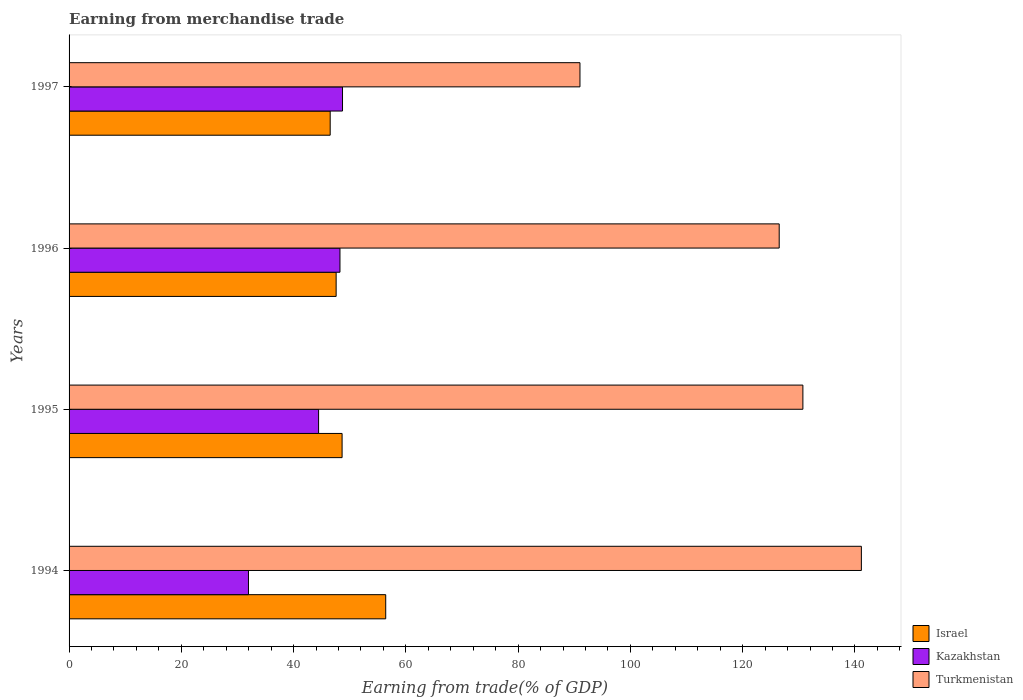How many different coloured bars are there?
Make the answer very short. 3. How many groups of bars are there?
Your response must be concise. 4. Are the number of bars on each tick of the Y-axis equal?
Offer a terse response. Yes. How many bars are there on the 3rd tick from the top?
Provide a short and direct response. 3. How many bars are there on the 4th tick from the bottom?
Your answer should be very brief. 3. What is the label of the 3rd group of bars from the top?
Make the answer very short. 1995. In how many cases, is the number of bars for a given year not equal to the number of legend labels?
Your response must be concise. 0. What is the earnings from trade in Israel in 1996?
Provide a short and direct response. 47.58. Across all years, what is the maximum earnings from trade in Kazakhstan?
Provide a short and direct response. 48.71. Across all years, what is the minimum earnings from trade in Kazakhstan?
Give a very brief answer. 31.96. In which year was the earnings from trade in Israel maximum?
Provide a short and direct response. 1994. What is the total earnings from trade in Turkmenistan in the graph?
Keep it short and to the point. 489.4. What is the difference between the earnings from trade in Kazakhstan in 1994 and that in 1995?
Your answer should be very brief. -12.49. What is the difference between the earnings from trade in Turkmenistan in 1994 and the earnings from trade in Kazakhstan in 1995?
Make the answer very short. 96.7. What is the average earnings from trade in Kazakhstan per year?
Offer a terse response. 43.35. In the year 1994, what is the difference between the earnings from trade in Kazakhstan and earnings from trade in Turkmenistan?
Your response must be concise. -109.19. In how many years, is the earnings from trade in Kazakhstan greater than 52 %?
Offer a very short reply. 0. What is the ratio of the earnings from trade in Israel in 1996 to that in 1997?
Your response must be concise. 1.02. What is the difference between the highest and the second highest earnings from trade in Israel?
Give a very brief answer. 7.77. What is the difference between the highest and the lowest earnings from trade in Turkmenistan?
Ensure brevity in your answer.  50.13. In how many years, is the earnings from trade in Israel greater than the average earnings from trade in Israel taken over all years?
Your answer should be very brief. 1. What does the 2nd bar from the top in 1995 represents?
Keep it short and to the point. Kazakhstan. What does the 2nd bar from the bottom in 1996 represents?
Ensure brevity in your answer.  Kazakhstan. How many years are there in the graph?
Your response must be concise. 4. What is the difference between two consecutive major ticks on the X-axis?
Offer a very short reply. 20. Are the values on the major ticks of X-axis written in scientific E-notation?
Offer a very short reply. No. Does the graph contain any zero values?
Your answer should be compact. No. How many legend labels are there?
Make the answer very short. 3. What is the title of the graph?
Your response must be concise. Earning from merchandise trade. What is the label or title of the X-axis?
Give a very brief answer. Earning from trade(% of GDP). What is the Earning from trade(% of GDP) in Israel in 1994?
Provide a short and direct response. 56.41. What is the Earning from trade(% of GDP) in Kazakhstan in 1994?
Make the answer very short. 31.96. What is the Earning from trade(% of GDP) of Turkmenistan in 1994?
Ensure brevity in your answer.  141.15. What is the Earning from trade(% of GDP) of Israel in 1995?
Your response must be concise. 48.64. What is the Earning from trade(% of GDP) of Kazakhstan in 1995?
Offer a terse response. 44.45. What is the Earning from trade(% of GDP) in Turkmenistan in 1995?
Your answer should be compact. 130.73. What is the Earning from trade(% of GDP) of Israel in 1996?
Offer a very short reply. 47.58. What is the Earning from trade(% of GDP) in Kazakhstan in 1996?
Provide a short and direct response. 48.26. What is the Earning from trade(% of GDP) of Turkmenistan in 1996?
Offer a very short reply. 126.51. What is the Earning from trade(% of GDP) of Israel in 1997?
Ensure brevity in your answer.  46.52. What is the Earning from trade(% of GDP) in Kazakhstan in 1997?
Your response must be concise. 48.71. What is the Earning from trade(% of GDP) in Turkmenistan in 1997?
Your answer should be very brief. 91.02. Across all years, what is the maximum Earning from trade(% of GDP) of Israel?
Provide a short and direct response. 56.41. Across all years, what is the maximum Earning from trade(% of GDP) in Kazakhstan?
Keep it short and to the point. 48.71. Across all years, what is the maximum Earning from trade(% of GDP) of Turkmenistan?
Offer a very short reply. 141.15. Across all years, what is the minimum Earning from trade(% of GDP) of Israel?
Give a very brief answer. 46.52. Across all years, what is the minimum Earning from trade(% of GDP) of Kazakhstan?
Provide a succinct answer. 31.96. Across all years, what is the minimum Earning from trade(% of GDP) of Turkmenistan?
Your response must be concise. 91.02. What is the total Earning from trade(% of GDP) in Israel in the graph?
Your answer should be very brief. 199.15. What is the total Earning from trade(% of GDP) in Kazakhstan in the graph?
Offer a very short reply. 173.39. What is the total Earning from trade(% of GDP) of Turkmenistan in the graph?
Keep it short and to the point. 489.4. What is the difference between the Earning from trade(% of GDP) of Israel in 1994 and that in 1995?
Ensure brevity in your answer.  7.77. What is the difference between the Earning from trade(% of GDP) in Kazakhstan in 1994 and that in 1995?
Your answer should be very brief. -12.49. What is the difference between the Earning from trade(% of GDP) in Turkmenistan in 1994 and that in 1995?
Your response must be concise. 10.42. What is the difference between the Earning from trade(% of GDP) of Israel in 1994 and that in 1996?
Give a very brief answer. 8.83. What is the difference between the Earning from trade(% of GDP) of Kazakhstan in 1994 and that in 1996?
Ensure brevity in your answer.  -16.3. What is the difference between the Earning from trade(% of GDP) of Turkmenistan in 1994 and that in 1996?
Give a very brief answer. 14.64. What is the difference between the Earning from trade(% of GDP) of Israel in 1994 and that in 1997?
Ensure brevity in your answer.  9.89. What is the difference between the Earning from trade(% of GDP) in Kazakhstan in 1994 and that in 1997?
Offer a terse response. -16.75. What is the difference between the Earning from trade(% of GDP) in Turkmenistan in 1994 and that in 1997?
Ensure brevity in your answer.  50.13. What is the difference between the Earning from trade(% of GDP) of Israel in 1995 and that in 1996?
Ensure brevity in your answer.  1.06. What is the difference between the Earning from trade(% of GDP) of Kazakhstan in 1995 and that in 1996?
Offer a terse response. -3.81. What is the difference between the Earning from trade(% of GDP) of Turkmenistan in 1995 and that in 1996?
Offer a very short reply. 4.22. What is the difference between the Earning from trade(% of GDP) of Israel in 1995 and that in 1997?
Make the answer very short. 2.12. What is the difference between the Earning from trade(% of GDP) of Kazakhstan in 1995 and that in 1997?
Your answer should be very brief. -4.26. What is the difference between the Earning from trade(% of GDP) of Turkmenistan in 1995 and that in 1997?
Your answer should be compact. 39.71. What is the difference between the Earning from trade(% of GDP) in Israel in 1996 and that in 1997?
Your answer should be very brief. 1.06. What is the difference between the Earning from trade(% of GDP) in Kazakhstan in 1996 and that in 1997?
Keep it short and to the point. -0.45. What is the difference between the Earning from trade(% of GDP) of Turkmenistan in 1996 and that in 1997?
Your response must be concise. 35.49. What is the difference between the Earning from trade(% of GDP) of Israel in 1994 and the Earning from trade(% of GDP) of Kazakhstan in 1995?
Keep it short and to the point. 11.96. What is the difference between the Earning from trade(% of GDP) in Israel in 1994 and the Earning from trade(% of GDP) in Turkmenistan in 1995?
Offer a terse response. -74.32. What is the difference between the Earning from trade(% of GDP) of Kazakhstan in 1994 and the Earning from trade(% of GDP) of Turkmenistan in 1995?
Give a very brief answer. -98.77. What is the difference between the Earning from trade(% of GDP) in Israel in 1994 and the Earning from trade(% of GDP) in Kazakhstan in 1996?
Provide a succinct answer. 8.15. What is the difference between the Earning from trade(% of GDP) of Israel in 1994 and the Earning from trade(% of GDP) of Turkmenistan in 1996?
Make the answer very short. -70.1. What is the difference between the Earning from trade(% of GDP) of Kazakhstan in 1994 and the Earning from trade(% of GDP) of Turkmenistan in 1996?
Provide a short and direct response. -94.55. What is the difference between the Earning from trade(% of GDP) in Israel in 1994 and the Earning from trade(% of GDP) in Kazakhstan in 1997?
Your answer should be compact. 7.7. What is the difference between the Earning from trade(% of GDP) of Israel in 1994 and the Earning from trade(% of GDP) of Turkmenistan in 1997?
Keep it short and to the point. -34.61. What is the difference between the Earning from trade(% of GDP) in Kazakhstan in 1994 and the Earning from trade(% of GDP) in Turkmenistan in 1997?
Your answer should be compact. -59.06. What is the difference between the Earning from trade(% of GDP) of Israel in 1995 and the Earning from trade(% of GDP) of Kazakhstan in 1996?
Provide a succinct answer. 0.38. What is the difference between the Earning from trade(% of GDP) in Israel in 1995 and the Earning from trade(% of GDP) in Turkmenistan in 1996?
Provide a short and direct response. -77.87. What is the difference between the Earning from trade(% of GDP) in Kazakhstan in 1995 and the Earning from trade(% of GDP) in Turkmenistan in 1996?
Offer a very short reply. -82.06. What is the difference between the Earning from trade(% of GDP) of Israel in 1995 and the Earning from trade(% of GDP) of Kazakhstan in 1997?
Provide a short and direct response. -0.08. What is the difference between the Earning from trade(% of GDP) in Israel in 1995 and the Earning from trade(% of GDP) in Turkmenistan in 1997?
Provide a succinct answer. -42.38. What is the difference between the Earning from trade(% of GDP) in Kazakhstan in 1995 and the Earning from trade(% of GDP) in Turkmenistan in 1997?
Provide a short and direct response. -46.56. What is the difference between the Earning from trade(% of GDP) of Israel in 1996 and the Earning from trade(% of GDP) of Kazakhstan in 1997?
Keep it short and to the point. -1.13. What is the difference between the Earning from trade(% of GDP) of Israel in 1996 and the Earning from trade(% of GDP) of Turkmenistan in 1997?
Provide a succinct answer. -43.44. What is the difference between the Earning from trade(% of GDP) of Kazakhstan in 1996 and the Earning from trade(% of GDP) of Turkmenistan in 1997?
Keep it short and to the point. -42.76. What is the average Earning from trade(% of GDP) in Israel per year?
Provide a short and direct response. 49.79. What is the average Earning from trade(% of GDP) of Kazakhstan per year?
Your answer should be compact. 43.35. What is the average Earning from trade(% of GDP) in Turkmenistan per year?
Give a very brief answer. 122.35. In the year 1994, what is the difference between the Earning from trade(% of GDP) of Israel and Earning from trade(% of GDP) of Kazakhstan?
Give a very brief answer. 24.45. In the year 1994, what is the difference between the Earning from trade(% of GDP) in Israel and Earning from trade(% of GDP) in Turkmenistan?
Ensure brevity in your answer.  -84.74. In the year 1994, what is the difference between the Earning from trade(% of GDP) of Kazakhstan and Earning from trade(% of GDP) of Turkmenistan?
Your answer should be compact. -109.19. In the year 1995, what is the difference between the Earning from trade(% of GDP) in Israel and Earning from trade(% of GDP) in Kazakhstan?
Provide a succinct answer. 4.19. In the year 1995, what is the difference between the Earning from trade(% of GDP) of Israel and Earning from trade(% of GDP) of Turkmenistan?
Offer a very short reply. -82.09. In the year 1995, what is the difference between the Earning from trade(% of GDP) in Kazakhstan and Earning from trade(% of GDP) in Turkmenistan?
Offer a very short reply. -86.28. In the year 1996, what is the difference between the Earning from trade(% of GDP) in Israel and Earning from trade(% of GDP) in Kazakhstan?
Your answer should be very brief. -0.68. In the year 1996, what is the difference between the Earning from trade(% of GDP) of Israel and Earning from trade(% of GDP) of Turkmenistan?
Make the answer very short. -78.93. In the year 1996, what is the difference between the Earning from trade(% of GDP) in Kazakhstan and Earning from trade(% of GDP) in Turkmenistan?
Your response must be concise. -78.25. In the year 1997, what is the difference between the Earning from trade(% of GDP) in Israel and Earning from trade(% of GDP) in Kazakhstan?
Your response must be concise. -2.2. In the year 1997, what is the difference between the Earning from trade(% of GDP) in Israel and Earning from trade(% of GDP) in Turkmenistan?
Keep it short and to the point. -44.5. In the year 1997, what is the difference between the Earning from trade(% of GDP) of Kazakhstan and Earning from trade(% of GDP) of Turkmenistan?
Offer a very short reply. -42.3. What is the ratio of the Earning from trade(% of GDP) in Israel in 1994 to that in 1995?
Make the answer very short. 1.16. What is the ratio of the Earning from trade(% of GDP) of Kazakhstan in 1994 to that in 1995?
Your response must be concise. 0.72. What is the ratio of the Earning from trade(% of GDP) of Turkmenistan in 1994 to that in 1995?
Your answer should be very brief. 1.08. What is the ratio of the Earning from trade(% of GDP) in Israel in 1994 to that in 1996?
Offer a terse response. 1.19. What is the ratio of the Earning from trade(% of GDP) of Kazakhstan in 1994 to that in 1996?
Ensure brevity in your answer.  0.66. What is the ratio of the Earning from trade(% of GDP) of Turkmenistan in 1994 to that in 1996?
Offer a very short reply. 1.12. What is the ratio of the Earning from trade(% of GDP) of Israel in 1994 to that in 1997?
Provide a succinct answer. 1.21. What is the ratio of the Earning from trade(% of GDP) in Kazakhstan in 1994 to that in 1997?
Ensure brevity in your answer.  0.66. What is the ratio of the Earning from trade(% of GDP) in Turkmenistan in 1994 to that in 1997?
Offer a terse response. 1.55. What is the ratio of the Earning from trade(% of GDP) of Israel in 1995 to that in 1996?
Keep it short and to the point. 1.02. What is the ratio of the Earning from trade(% of GDP) in Kazakhstan in 1995 to that in 1996?
Provide a short and direct response. 0.92. What is the ratio of the Earning from trade(% of GDP) in Turkmenistan in 1995 to that in 1996?
Ensure brevity in your answer.  1.03. What is the ratio of the Earning from trade(% of GDP) in Israel in 1995 to that in 1997?
Provide a succinct answer. 1.05. What is the ratio of the Earning from trade(% of GDP) in Kazakhstan in 1995 to that in 1997?
Offer a very short reply. 0.91. What is the ratio of the Earning from trade(% of GDP) of Turkmenistan in 1995 to that in 1997?
Offer a very short reply. 1.44. What is the ratio of the Earning from trade(% of GDP) in Israel in 1996 to that in 1997?
Give a very brief answer. 1.02. What is the ratio of the Earning from trade(% of GDP) in Kazakhstan in 1996 to that in 1997?
Ensure brevity in your answer.  0.99. What is the ratio of the Earning from trade(% of GDP) of Turkmenistan in 1996 to that in 1997?
Ensure brevity in your answer.  1.39. What is the difference between the highest and the second highest Earning from trade(% of GDP) of Israel?
Your answer should be very brief. 7.77. What is the difference between the highest and the second highest Earning from trade(% of GDP) of Kazakhstan?
Your answer should be compact. 0.45. What is the difference between the highest and the second highest Earning from trade(% of GDP) of Turkmenistan?
Your response must be concise. 10.42. What is the difference between the highest and the lowest Earning from trade(% of GDP) of Israel?
Your answer should be compact. 9.89. What is the difference between the highest and the lowest Earning from trade(% of GDP) of Kazakhstan?
Keep it short and to the point. 16.75. What is the difference between the highest and the lowest Earning from trade(% of GDP) of Turkmenistan?
Your answer should be compact. 50.13. 